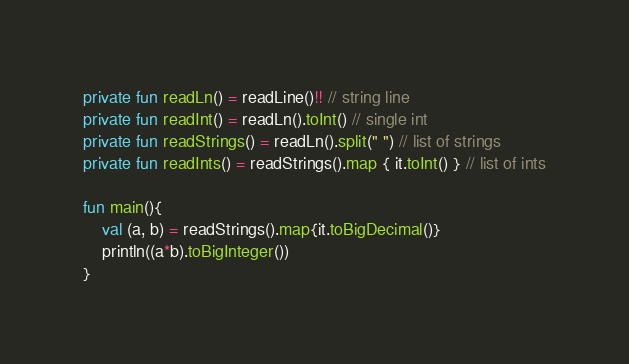<code> <loc_0><loc_0><loc_500><loc_500><_Kotlin_>private fun readLn() = readLine()!! // string line
private fun readInt() = readLn().toInt() // single int
private fun readStrings() = readLn().split(" ") // list of strings
private fun readInts() = readStrings().map { it.toInt() } // list of ints

fun main(){
    val (a, b) = readStrings().map{it.toBigDecimal()}
    println((a*b).toBigInteger())
}</code> 